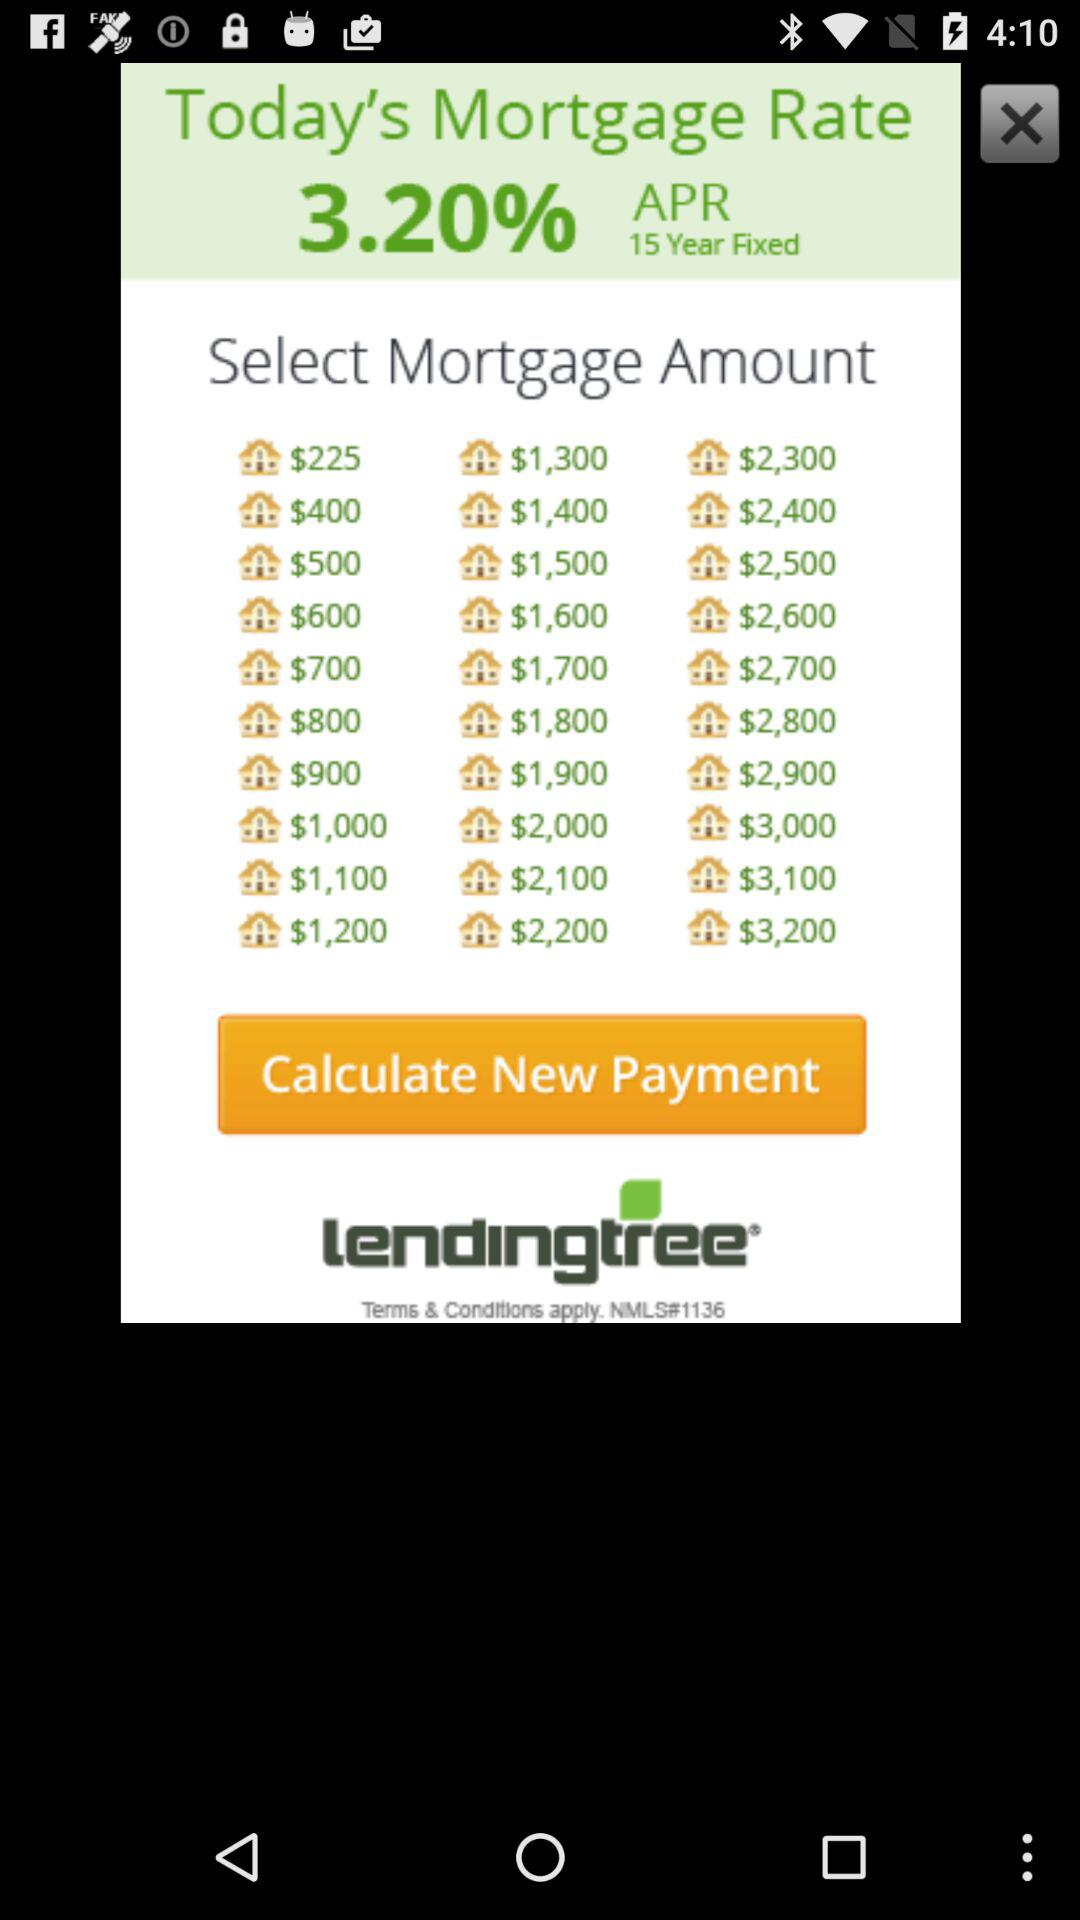What is the fixed duration? The fixed duration is 15 years. 